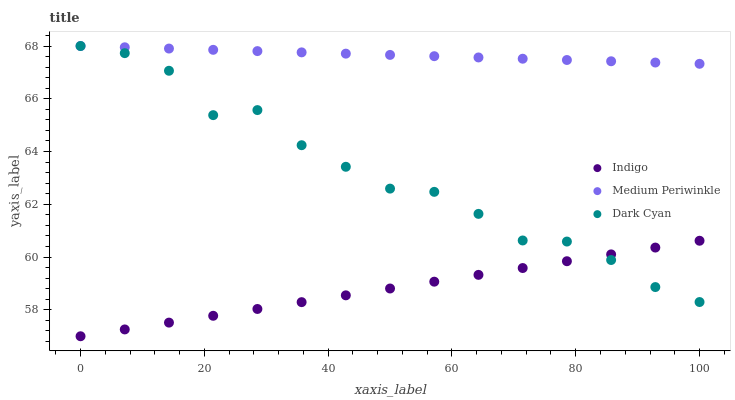Does Indigo have the minimum area under the curve?
Answer yes or no. Yes. Does Medium Periwinkle have the maximum area under the curve?
Answer yes or no. Yes. Does Medium Periwinkle have the minimum area under the curve?
Answer yes or no. No. Does Indigo have the maximum area under the curve?
Answer yes or no. No. Is Indigo the smoothest?
Answer yes or no. Yes. Is Dark Cyan the roughest?
Answer yes or no. Yes. Is Medium Periwinkle the smoothest?
Answer yes or no. No. Is Medium Periwinkle the roughest?
Answer yes or no. No. Does Indigo have the lowest value?
Answer yes or no. Yes. Does Medium Periwinkle have the lowest value?
Answer yes or no. No. Does Medium Periwinkle have the highest value?
Answer yes or no. Yes. Does Indigo have the highest value?
Answer yes or no. No. Is Indigo less than Medium Periwinkle?
Answer yes or no. Yes. Is Medium Periwinkle greater than Indigo?
Answer yes or no. Yes. Does Medium Periwinkle intersect Dark Cyan?
Answer yes or no. Yes. Is Medium Periwinkle less than Dark Cyan?
Answer yes or no. No. Is Medium Periwinkle greater than Dark Cyan?
Answer yes or no. No. Does Indigo intersect Medium Periwinkle?
Answer yes or no. No. 